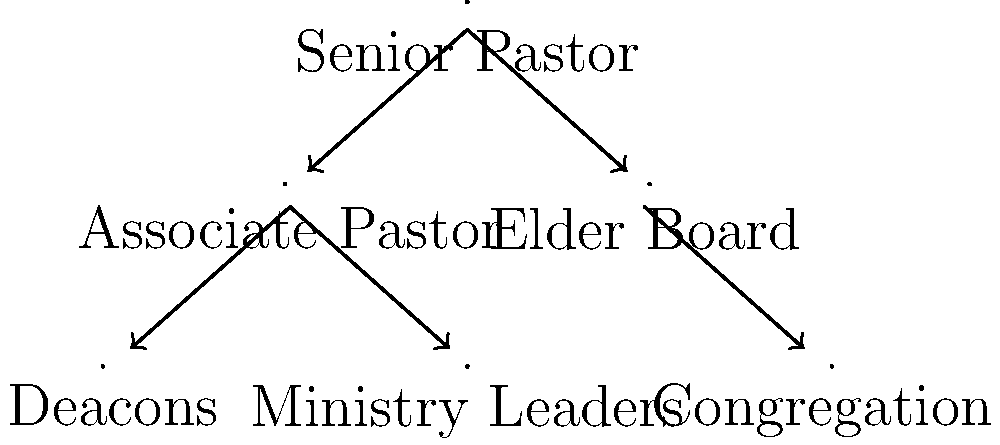In the given church leadership hierarchy chart, which position is directly responsible for overseeing both the Associate Pastor and the Elder Board? To answer this question, we need to analyze the church leadership hierarchy chart step-by-step:

1. The chart shows a traditional complementarian church structure.
2. At the top of the hierarchy is the "Senior Pastor" position.
3. Directly below the Senior Pastor, we see two positions:
   a. "Associate Pastor" on the left
   b. "Elder Board" on the right
4. Arrows are drawn from the Senior Pastor to both the Associate Pastor and the Elder Board.
5. These arrows indicate a direct line of authority and oversight from the Senior Pastor to these two positions.
6. No other position in the chart has direct arrows to both the Associate Pastor and the Elder Board.

Therefore, based on this hierarchical structure, the Senior Pastor is the position directly responsible for overseeing both the Associate Pastor and the Elder Board.
Answer: Senior Pastor 